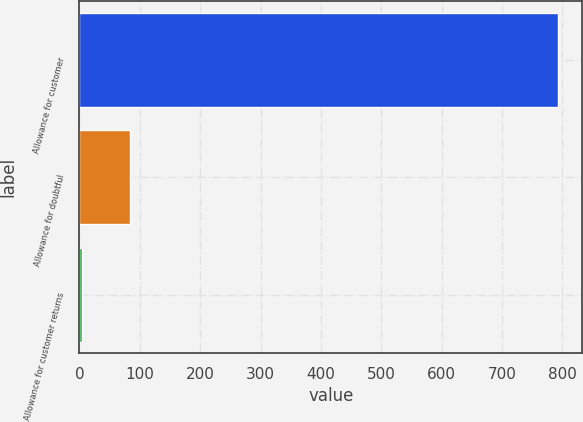Convert chart to OTSL. <chart><loc_0><loc_0><loc_500><loc_500><bar_chart><fcel>Allowance for customer<fcel>Allowance for doubtful<fcel>Allowance for customer returns<nl><fcel>793<fcel>83.8<fcel>5<nl></chart> 